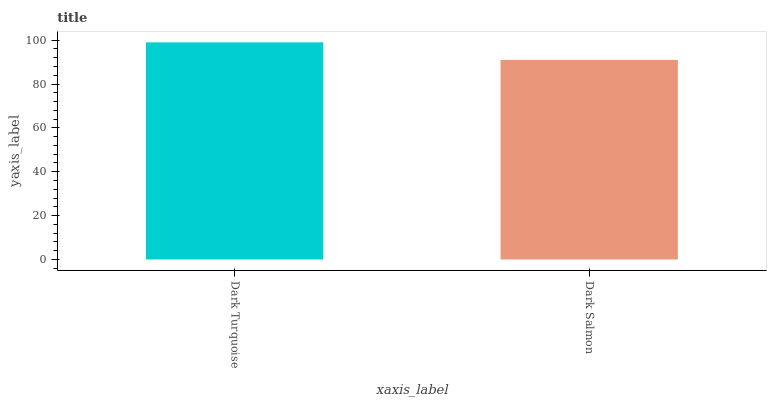Is Dark Salmon the minimum?
Answer yes or no. Yes. Is Dark Turquoise the maximum?
Answer yes or no. Yes. Is Dark Salmon the maximum?
Answer yes or no. No. Is Dark Turquoise greater than Dark Salmon?
Answer yes or no. Yes. Is Dark Salmon less than Dark Turquoise?
Answer yes or no. Yes. Is Dark Salmon greater than Dark Turquoise?
Answer yes or no. No. Is Dark Turquoise less than Dark Salmon?
Answer yes or no. No. Is Dark Turquoise the high median?
Answer yes or no. Yes. Is Dark Salmon the low median?
Answer yes or no. Yes. Is Dark Salmon the high median?
Answer yes or no. No. Is Dark Turquoise the low median?
Answer yes or no. No. 